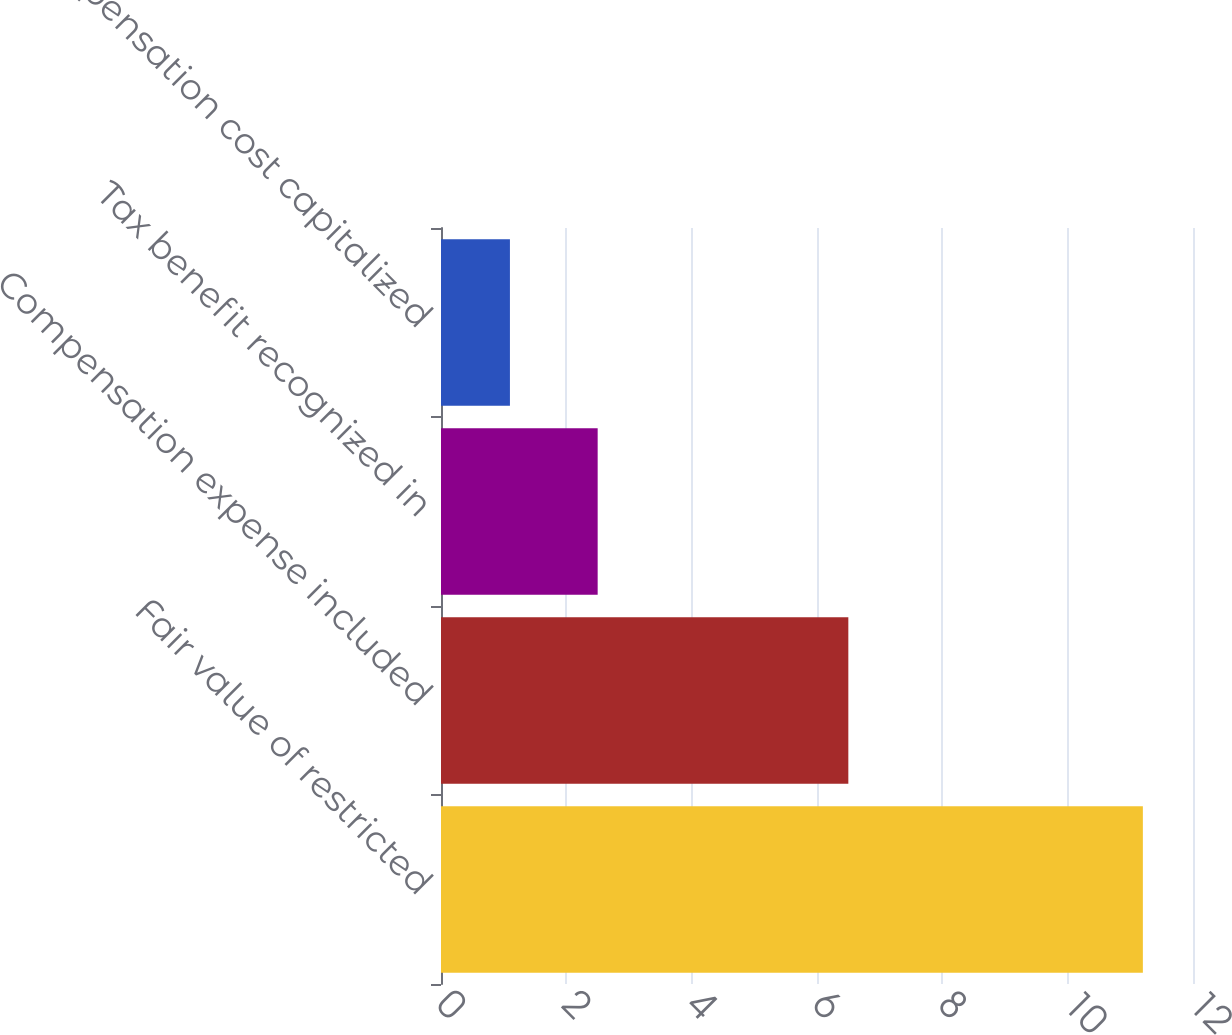Convert chart. <chart><loc_0><loc_0><loc_500><loc_500><bar_chart><fcel>Fair value of restricted<fcel>Compensation expense included<fcel>Tax benefit recognized in<fcel>Compensation cost capitalized<nl><fcel>11.2<fcel>6.5<fcel>2.5<fcel>1.1<nl></chart> 